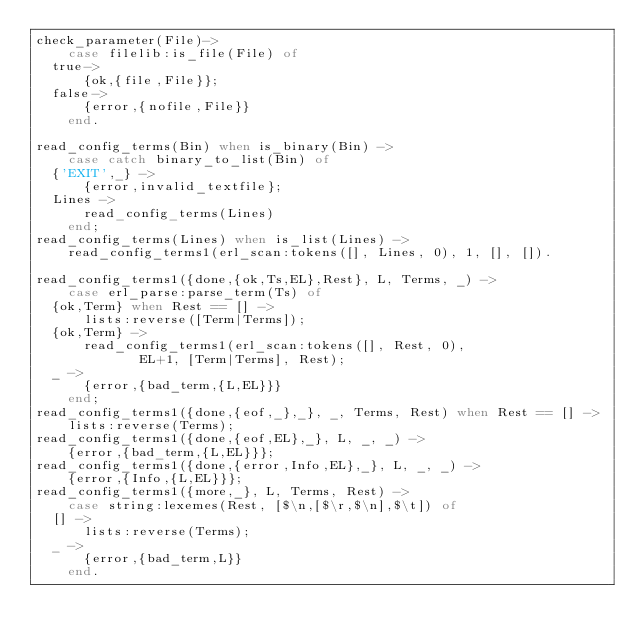Convert code to text. <code><loc_0><loc_0><loc_500><loc_500><_Erlang_>check_parameter(File)->
    case filelib:is_file(File) of
	true->
	    {ok,{file,File}};
	false->
	    {error,{nofile,File}}
    end.

read_config_terms(Bin) when is_binary(Bin) ->
    case catch binary_to_list(Bin) of
	{'EXIT',_} ->
	    {error,invalid_textfile};
	Lines ->
	    read_config_terms(Lines)
    end;
read_config_terms(Lines) when is_list(Lines) ->
    read_config_terms1(erl_scan:tokens([], Lines, 0), 1, [], []).

read_config_terms1({done,{ok,Ts,EL},Rest}, L, Terms, _) ->
    case erl_parse:parse_term(Ts) of
	{ok,Term} when Rest == [] ->
	    lists:reverse([Term|Terms]);
	{ok,Term} ->
	    read_config_terms1(erl_scan:tokens([], Rest, 0),
			       EL+1, [Term|Terms], Rest);
	_ ->
	    {error,{bad_term,{L,EL}}}
    end;
read_config_terms1({done,{eof,_},_}, _, Terms, Rest) when Rest == [] ->
    lists:reverse(Terms);
read_config_terms1({done,{eof,EL},_}, L, _, _) ->
    {error,{bad_term,{L,EL}}};
read_config_terms1({done,{error,Info,EL},_}, L, _, _) ->
    {error,{Info,{L,EL}}};
read_config_terms1({more,_}, L, Terms, Rest) ->
    case string:lexemes(Rest, [$\n,[$\r,$\n],$\t]) of
	[] ->
	    lists:reverse(Terms);
	_ ->
	    {error,{bad_term,L}}
    end.
</code> 